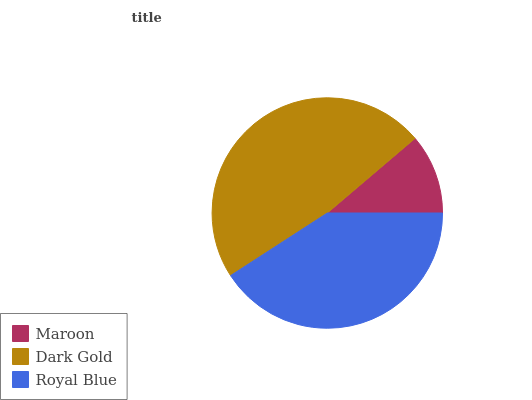Is Maroon the minimum?
Answer yes or no. Yes. Is Dark Gold the maximum?
Answer yes or no. Yes. Is Royal Blue the minimum?
Answer yes or no. No. Is Royal Blue the maximum?
Answer yes or no. No. Is Dark Gold greater than Royal Blue?
Answer yes or no. Yes. Is Royal Blue less than Dark Gold?
Answer yes or no. Yes. Is Royal Blue greater than Dark Gold?
Answer yes or no. No. Is Dark Gold less than Royal Blue?
Answer yes or no. No. Is Royal Blue the high median?
Answer yes or no. Yes. Is Royal Blue the low median?
Answer yes or no. Yes. Is Dark Gold the high median?
Answer yes or no. No. Is Dark Gold the low median?
Answer yes or no. No. 